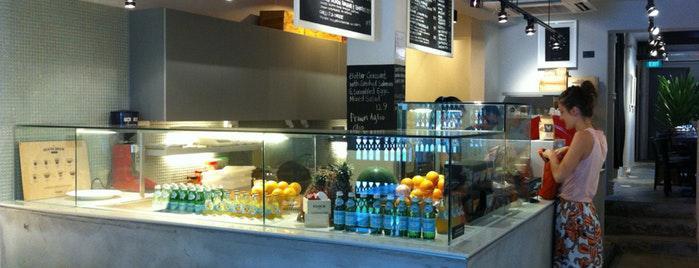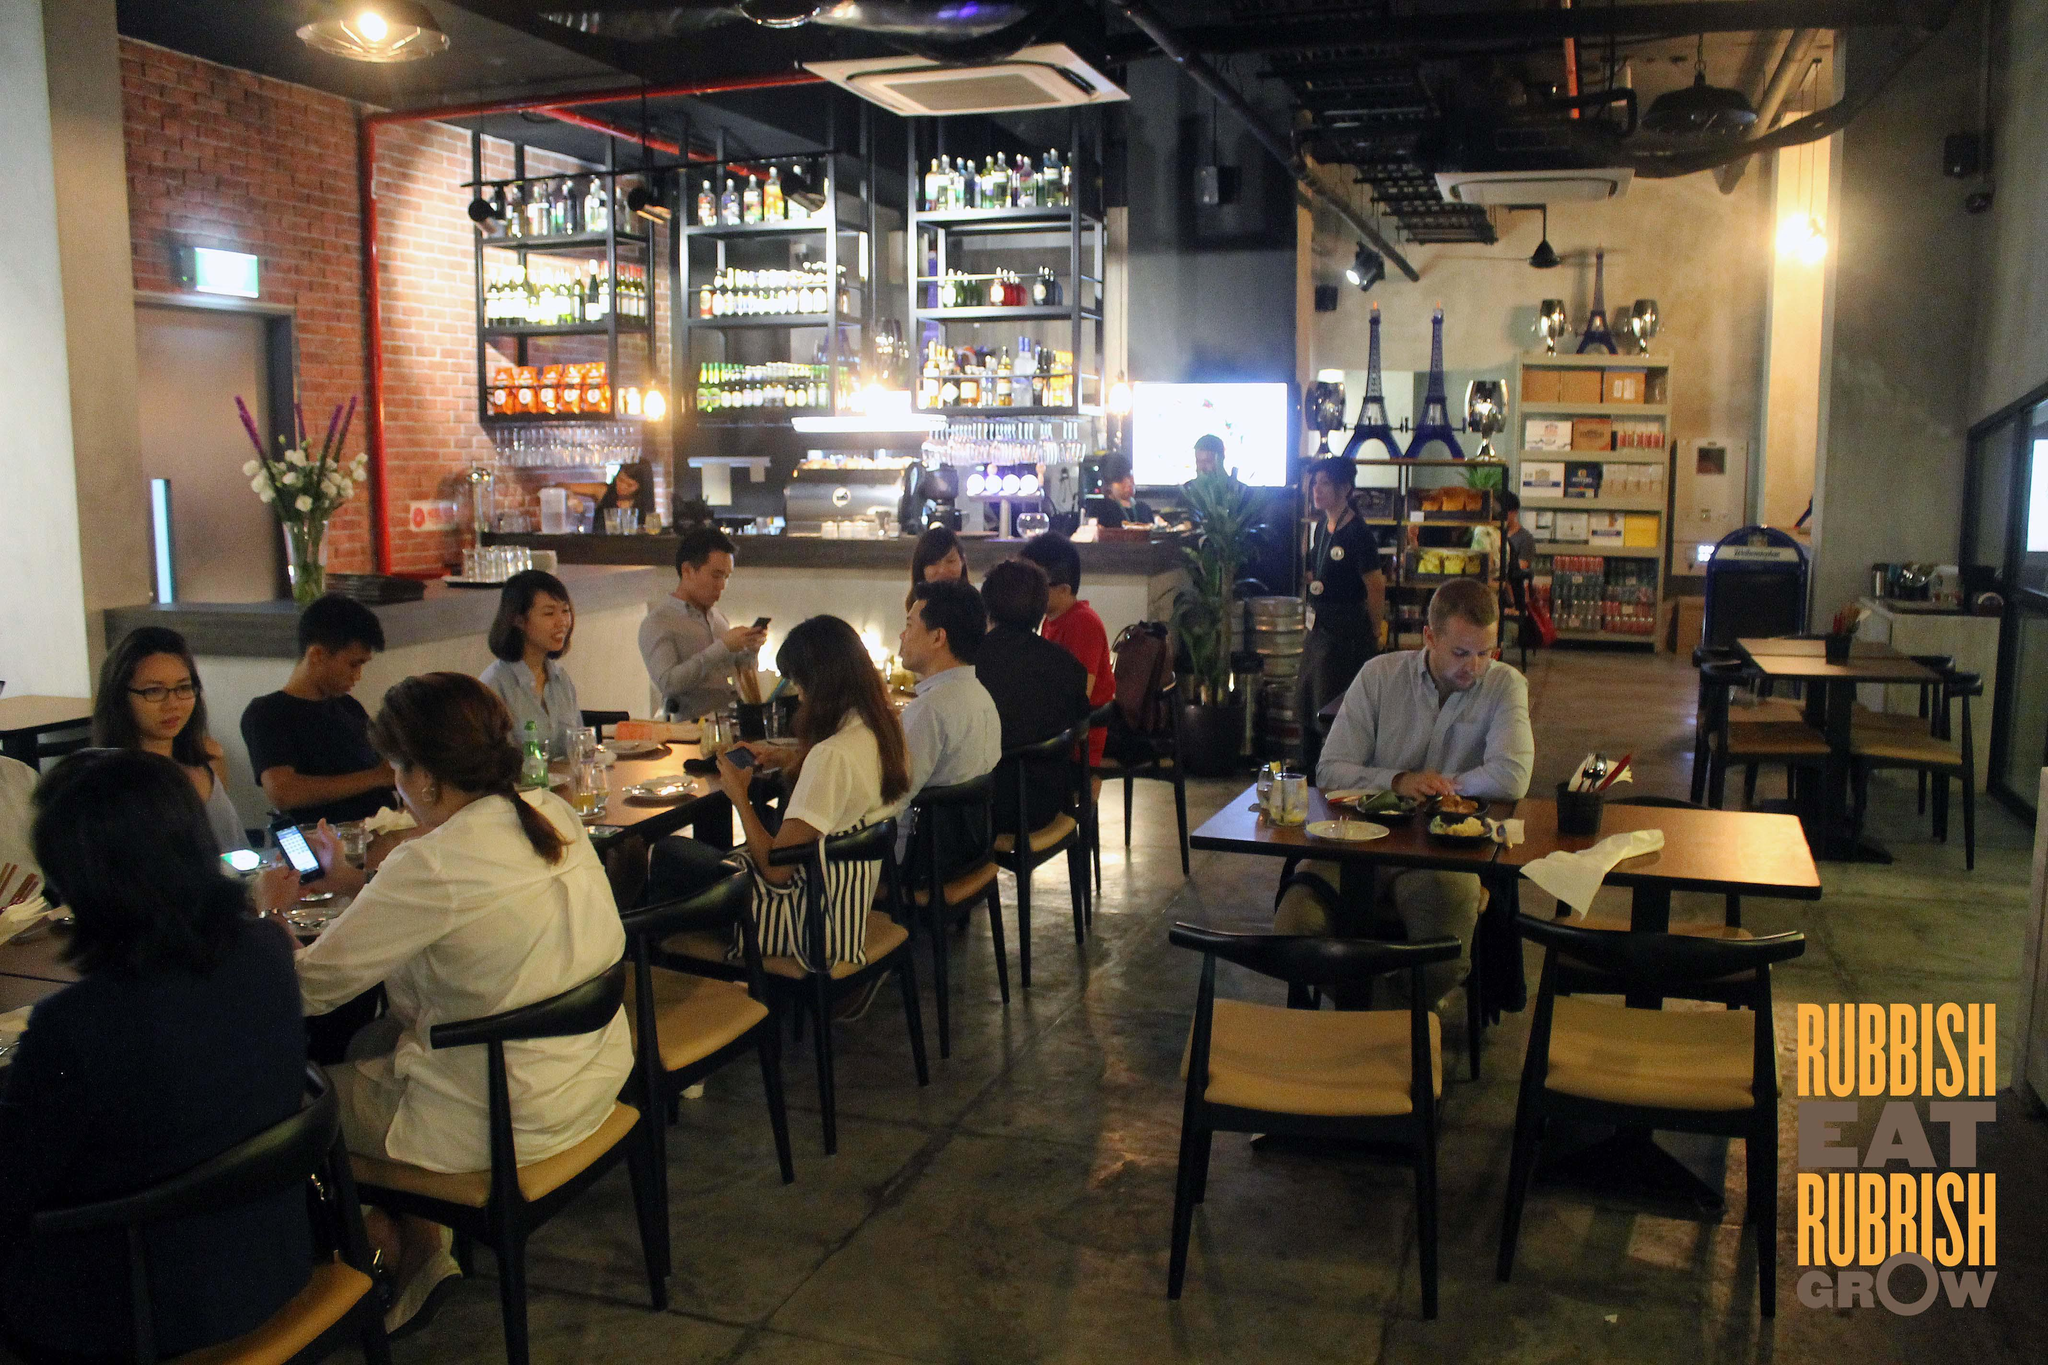The first image is the image on the left, the second image is the image on the right. For the images displayed, is the sentence "The left image features tiered shelves behind a glass case filled with side-by-side rectangular trays of baked goods, each with an oval cut-out tray handle facing the glass front." factually correct? Answer yes or no. No. The first image is the image on the left, the second image is the image on the right. Considering the images on both sides, is "One of the shops advertises 'dough & grains'." valid? Answer yes or no. No. 